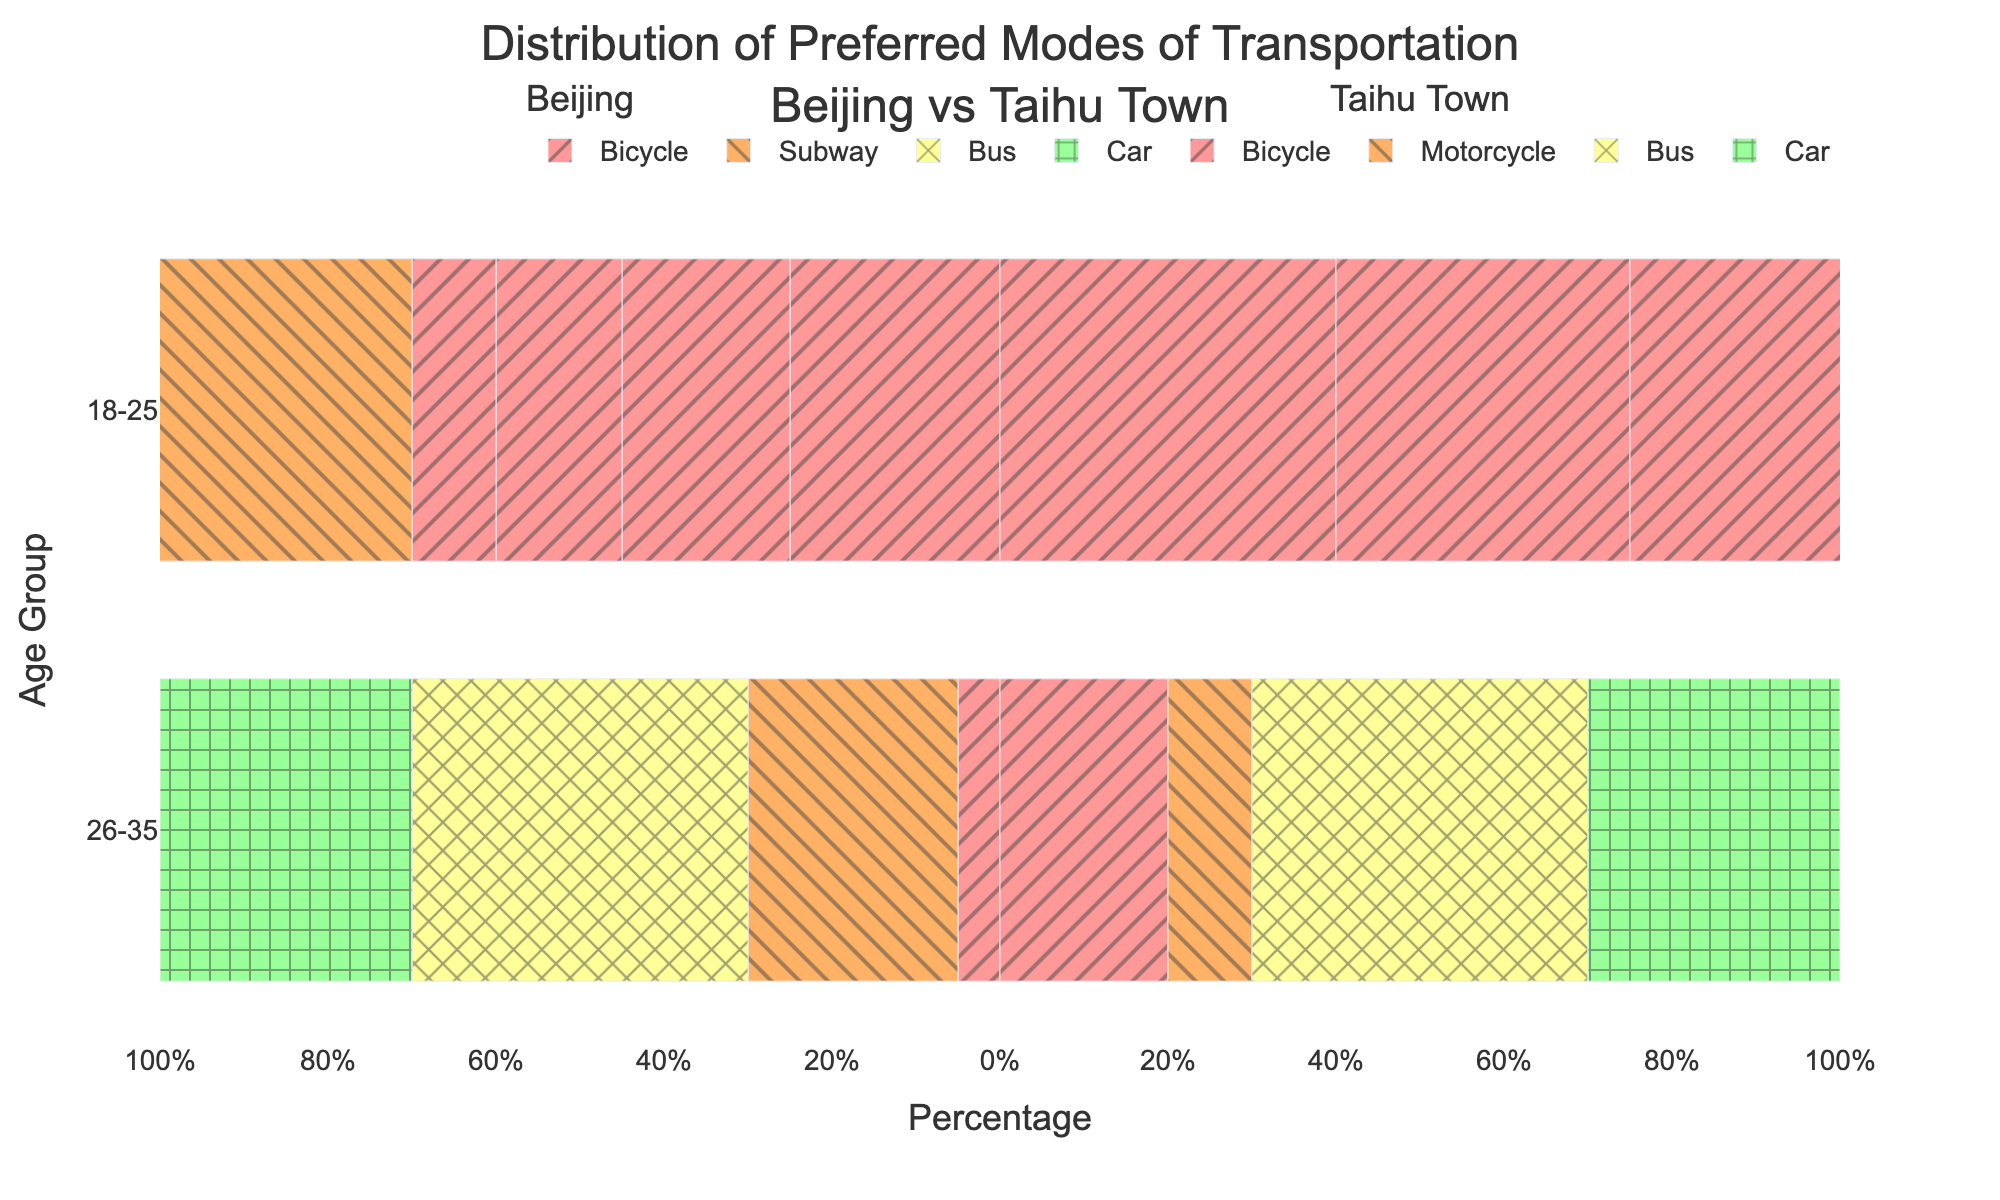Which age group in Beijing prefers buses the most? Look at the bar lengths for buses in Beijing across all age groups. The longest bar represents the age group of 56-65 with 40%.
Answer: 56-65 Which mode of transportation do people aged 18-25 in Taihu Town prefer the most? Check the positive bars for the 18-25 age group in Taihu Town. The longest bar is for bicycles with 40%.
Answer: Bicycle How does the percentage of bus users aged 36-45 in Taihu Town compare to those in Beijing? Compare the lengths of the bus bars for the age group 36-45 in both locations. Taihu Town has 30% and Beijing has 30%.
Answer: Equal Calculate the difference in the percentage of subway users aged 26-35 between Beijing and Taihu Town. In Beijing, this age group has 40% subway users. For Taihu Town, this percentage is 0%. The difference is 40% - 0% = 40%.
Answer: 40% What can you say about the environmental awareness of bicycle users in Taihu Town across all age groups? All bicycle users in Taihu Town across all age groups exhibit high environmental awareness as indicated in the data.
Answer: High Is there any age group in Beijing where the car is the predominant mode of transportation? Look at the negative bars for cars across all age groups in Beijing. No age group has cars as the predominant mode of transport.
Answer: No Which mode of transportation has the same percentage for the 46-55 age group in both Beijing and Taihu Town? Compare the lengths of bars for each mode in the 46-55 age group across both locations. Buses have the same percentage of 35%.
Answer: Bus In Taihu Town, for which age group is the use of motorcycles the lowest? Check the lengths of the positive bars for motorcycles across all age groups in Taihu Town. The age group 56-65 has the lowest at 10%.
Answer: 56-65 Compare the usage of bikes between the youngest and oldest age groups in Beijing. What do you observe? Compare the lengths of the bicycle bars for age groups 18-25 and 56-65 in Beijing. The 18-25 group has 25% while the 56-65 group has 5%, so there is a decrease with age.
Answer: Decrease with age Which location and age group combination has the highest subway usage? Search both positive and negative bars for the subway. The highest is for the age group 18-25 in Beijing with 45%.
Answer: 18-25 in Beijing 